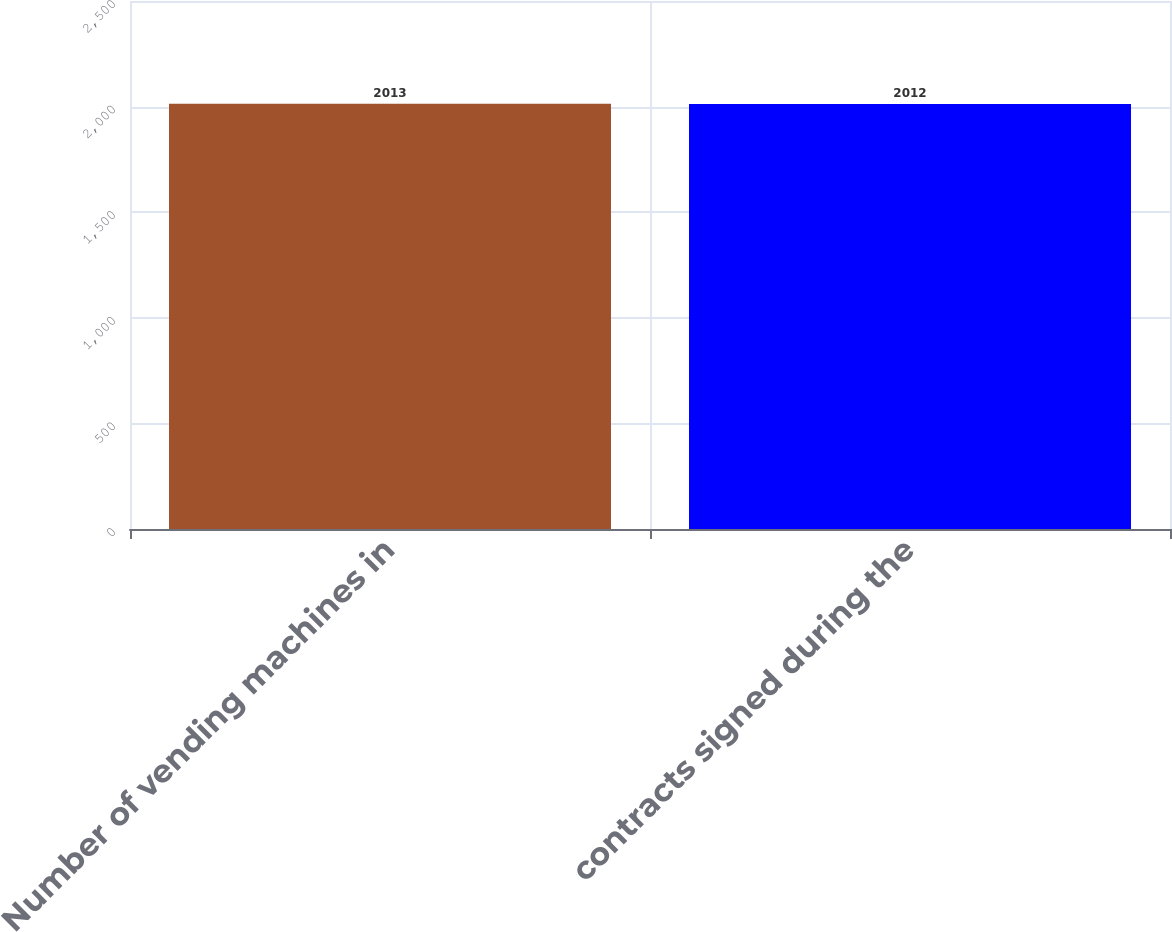Convert chart. <chart><loc_0><loc_0><loc_500><loc_500><bar_chart><fcel>Number of vending machines in<fcel>contracts signed during the<nl><fcel>2013<fcel>2012<nl></chart> 